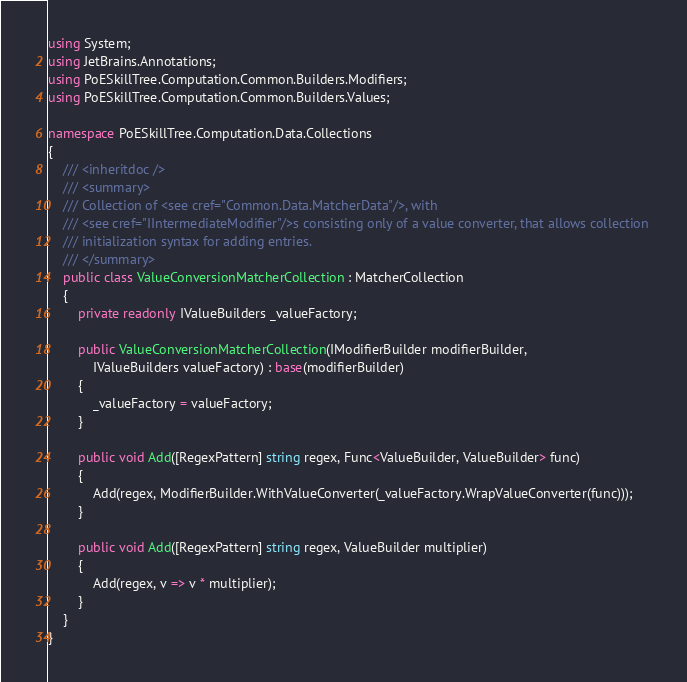<code> <loc_0><loc_0><loc_500><loc_500><_C#_>using System;
using JetBrains.Annotations;
using PoESkillTree.Computation.Common.Builders.Modifiers;
using PoESkillTree.Computation.Common.Builders.Values;

namespace PoESkillTree.Computation.Data.Collections
{
    /// <inheritdoc />
    /// <summary>
    /// Collection of <see cref="Common.Data.MatcherData"/>, with 
    /// <see cref="IIntermediateModifier"/>s consisting only of a value converter, that allows collection 
    /// initialization syntax for adding entries.
    /// </summary>
    public class ValueConversionMatcherCollection : MatcherCollection
    {
        private readonly IValueBuilders _valueFactory;

        public ValueConversionMatcherCollection(IModifierBuilder modifierBuilder,
            IValueBuilders valueFactory) : base(modifierBuilder)
        {
            _valueFactory = valueFactory;
        }

        public void Add([RegexPattern] string regex, Func<ValueBuilder, ValueBuilder> func)
        {
            Add(regex, ModifierBuilder.WithValueConverter(_valueFactory.WrapValueConverter(func)));
        }

        public void Add([RegexPattern] string regex, ValueBuilder multiplier)
        {
            Add(regex, v => v * multiplier);
        }
    }
}</code> 